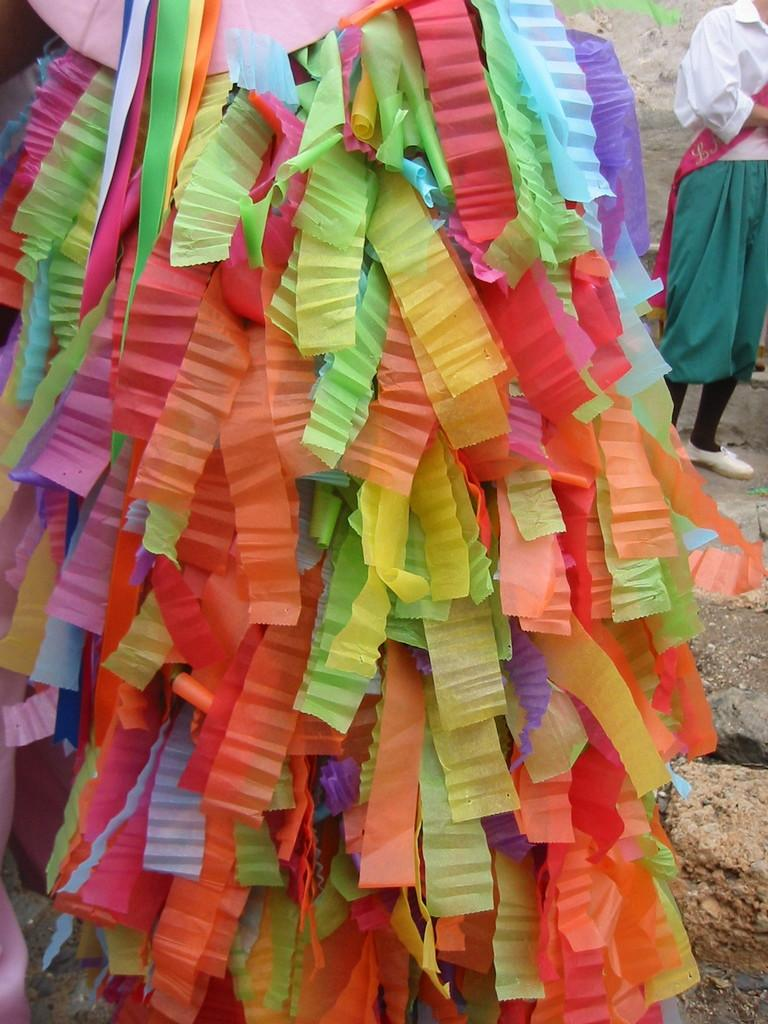What can be seen in the foreground of the image? There are various colored ribbons in the foreground of the image. Where is the person standing in the image? The person is standing towards the right side of the image. What can be seen towards the right side of the image? Land is visible towards the right side of the image. How many tickets does the person have in their hand in the image? There is no mention of tickets in the image, so it cannot be determined if the person has any. Is the person's brother standing next to them in the image? There is no mention of a brother or any other person in the image, so it cannot be determined if the person's brother is present. 